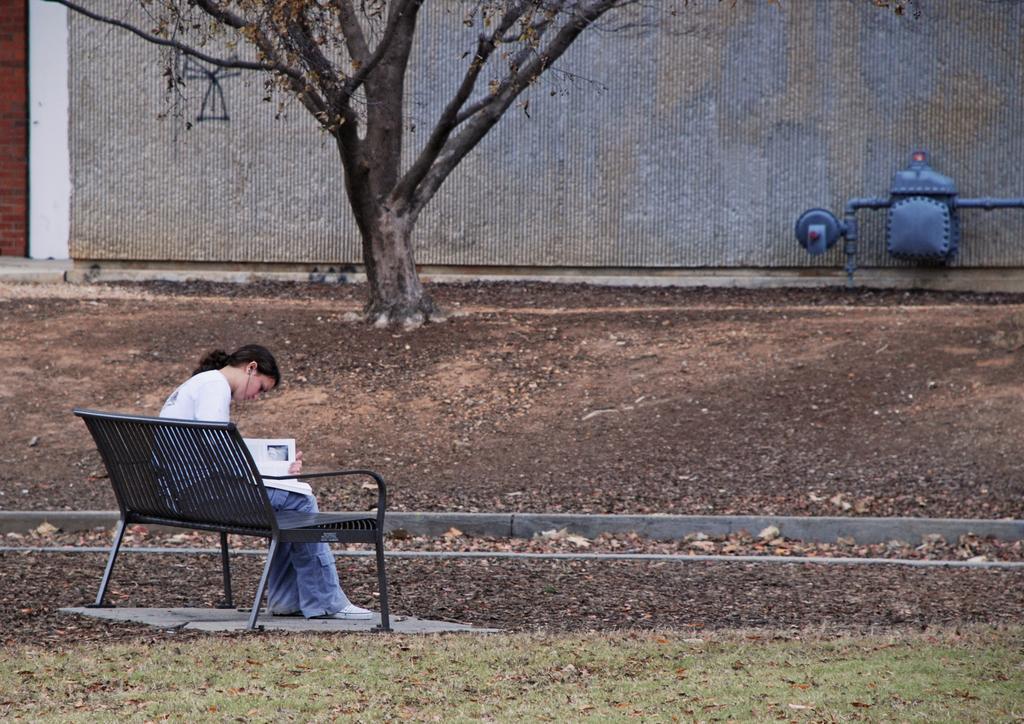Describe this image in one or two sentences. In this image a woman sitting on a bench, in the background there is a wall, in the top right there is a pipe machine. 